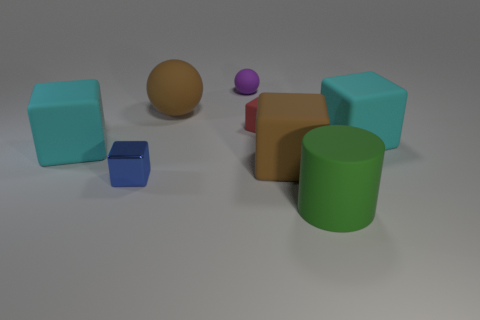Subtract all cyan cubes. How many cubes are left? 3 Subtract all gray cylinders. How many cyan cubes are left? 2 Subtract 1 cylinders. How many cylinders are left? 0 Add 1 red metallic blocks. How many objects exist? 9 Subtract all blue blocks. How many blocks are left? 4 Subtract all yellow cubes. Subtract all brown spheres. How many cubes are left? 5 Subtract all large red rubber blocks. Subtract all big brown balls. How many objects are left? 7 Add 4 green cylinders. How many green cylinders are left? 5 Add 6 big brown balls. How many big brown balls exist? 7 Subtract 1 green cylinders. How many objects are left? 7 